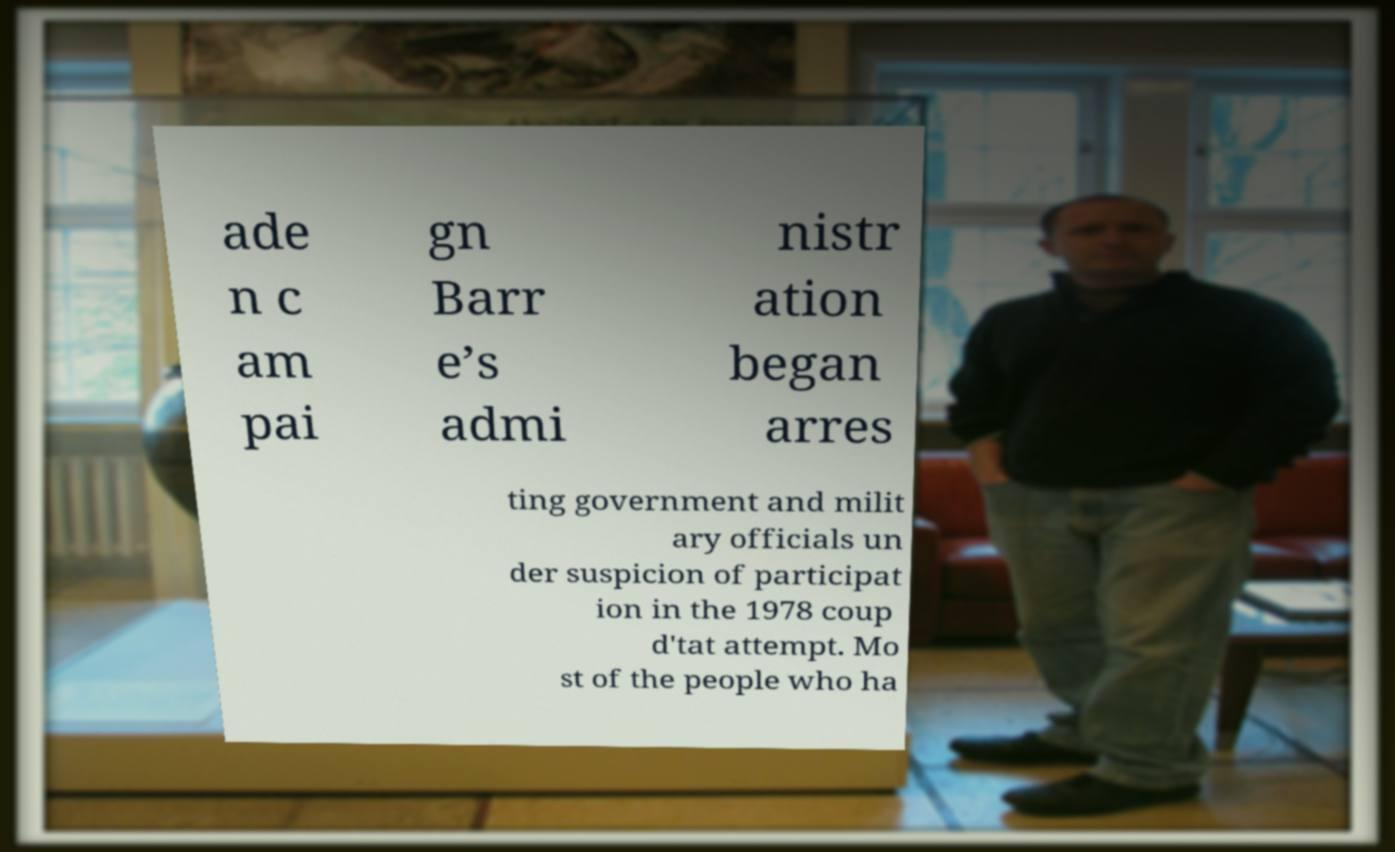Can you read and provide the text displayed in the image?This photo seems to have some interesting text. Can you extract and type it out for me? ade n c am pai gn Barr e’s admi nistr ation began arres ting government and milit ary officials un der suspicion of participat ion in the 1978 coup d'tat attempt. Mo st of the people who ha 